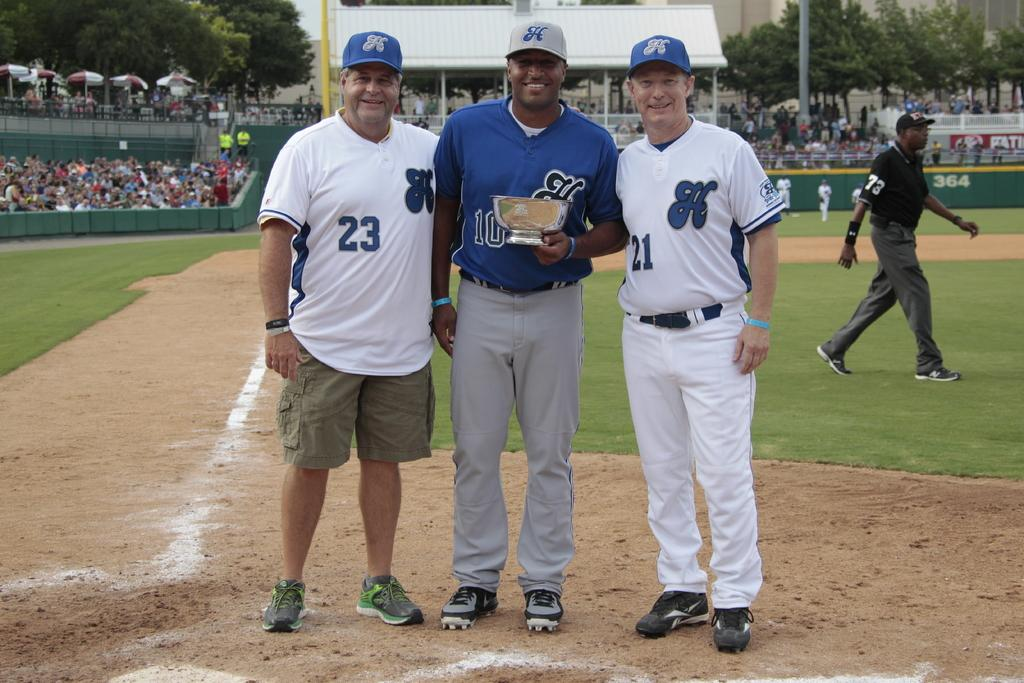<image>
Offer a succinct explanation of the picture presented. Men posing for a photo with one wearing the number 23. 